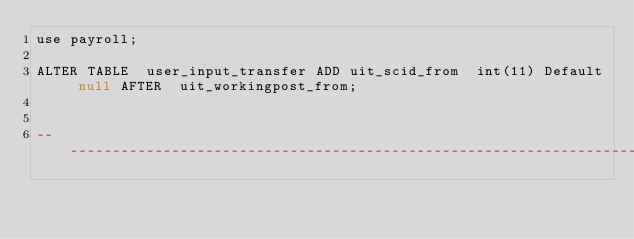Convert code to text. <code><loc_0><loc_0><loc_500><loc_500><_SQL_>use payroll;

ALTER TABLE  user_input_transfer ADD uit_scid_from  int(11) Default null AFTER  uit_workingpost_from;


-- ------------------------------------------------------------------------------------------------

</code> 